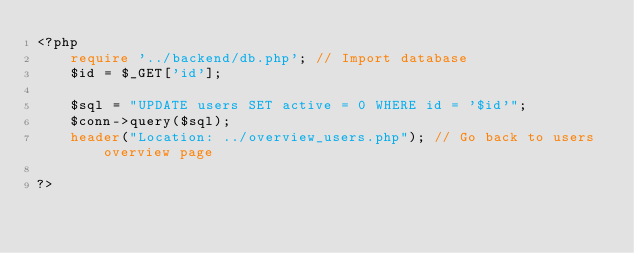Convert code to text. <code><loc_0><loc_0><loc_500><loc_500><_PHP_><?php
	require '../backend/db.php'; // Import database
	$id = $_GET['id'];

	$sql = "UPDATE users SET active = 0 WHERE id = '$id'";
	$conn->query($sql);
	header("Location: ../overview_users.php"); // Go back to users overview page

?></code> 